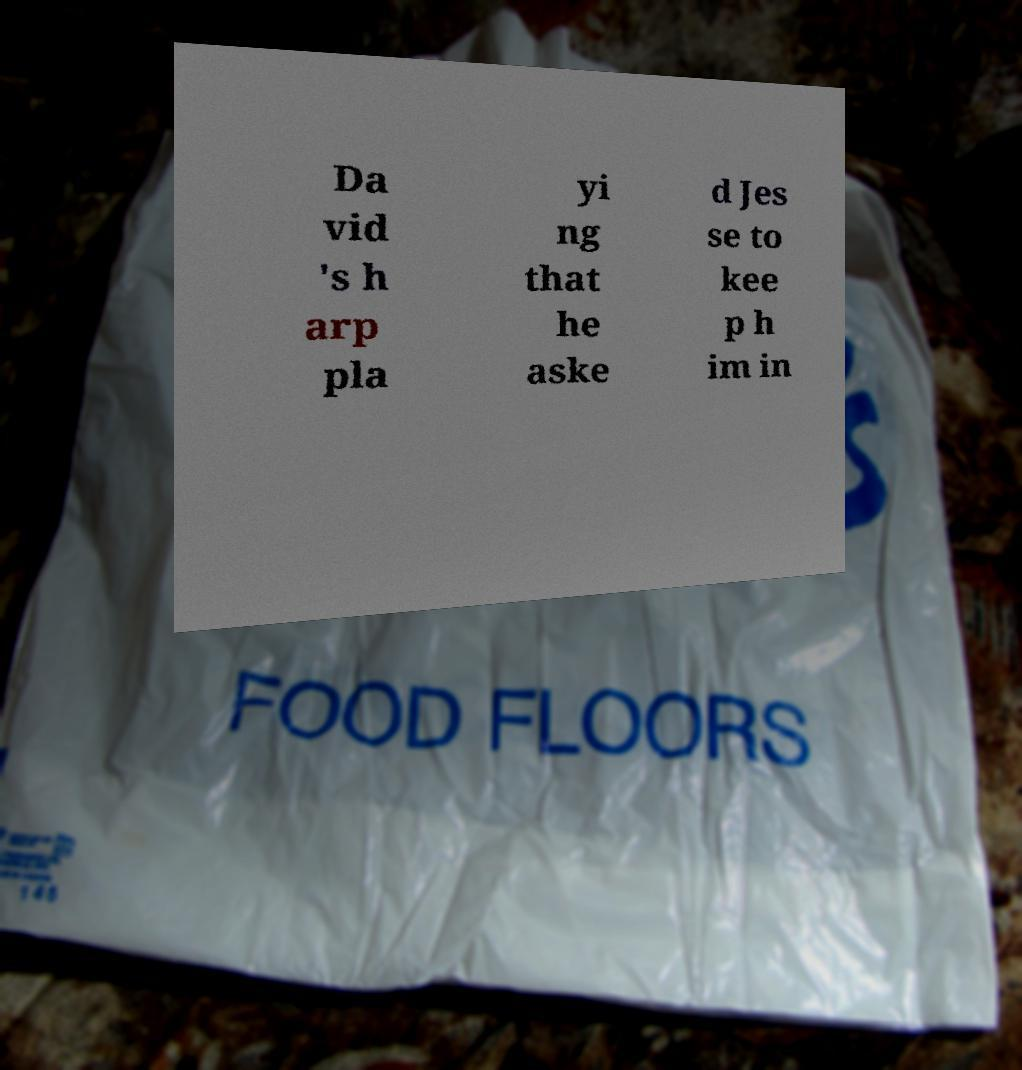Can you accurately transcribe the text from the provided image for me? Da vid 's h arp pla yi ng that he aske d Jes se to kee p h im in 